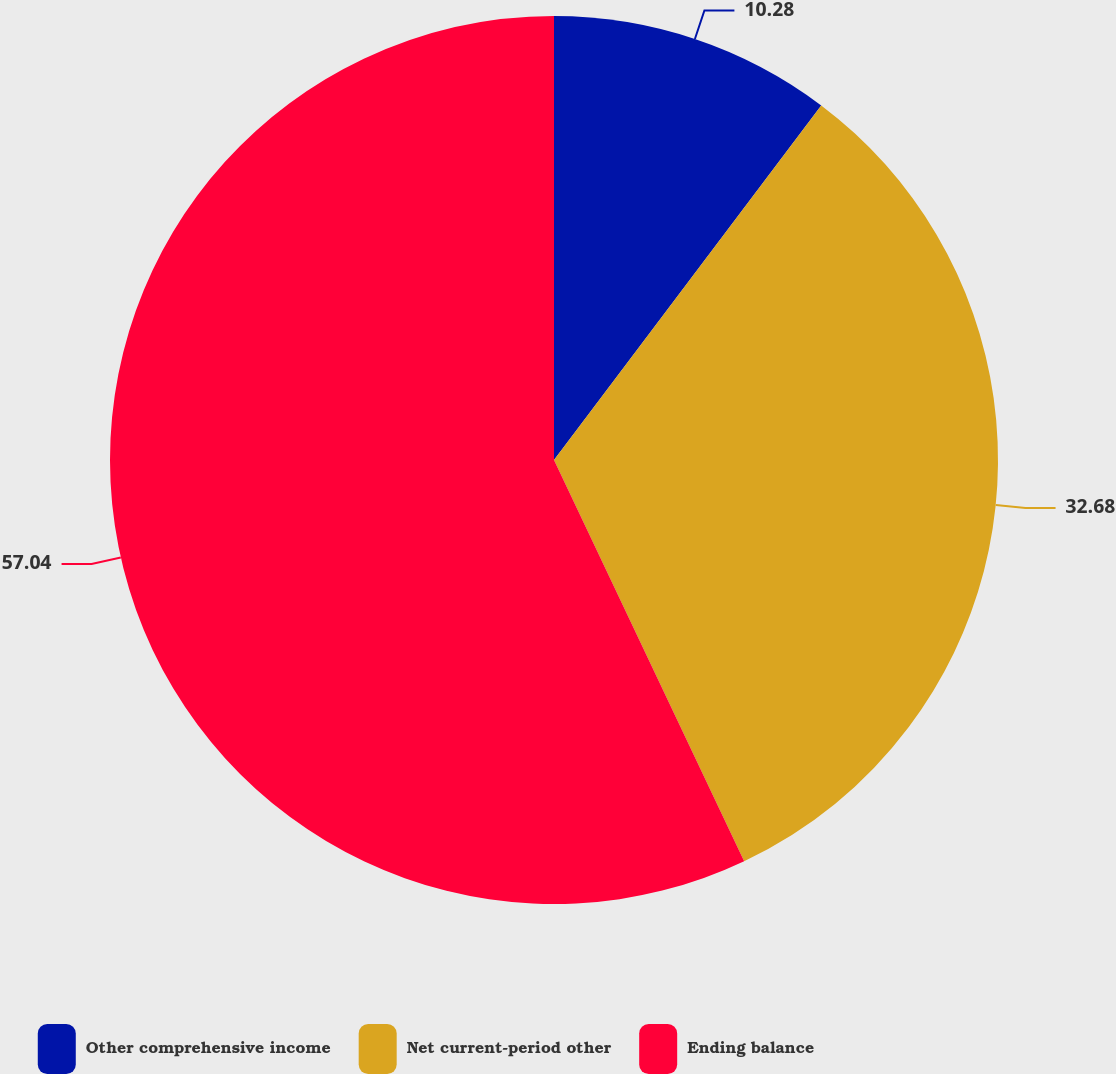Convert chart. <chart><loc_0><loc_0><loc_500><loc_500><pie_chart><fcel>Other comprehensive income<fcel>Net current-period other<fcel>Ending balance<nl><fcel>10.28%<fcel>32.68%<fcel>57.05%<nl></chart> 